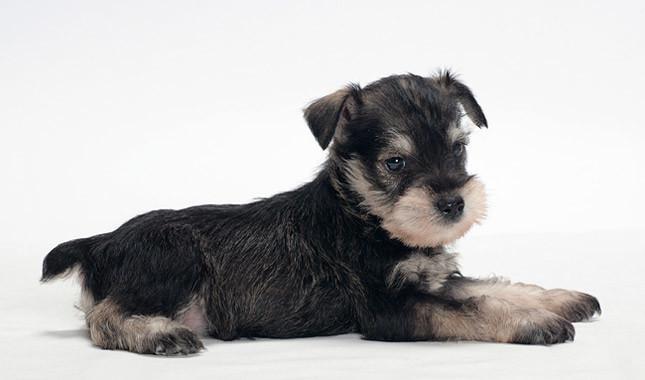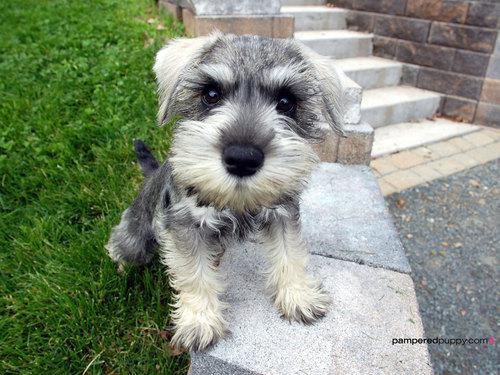The first image is the image on the left, the second image is the image on the right. Assess this claim about the two images: "Right image shows at least one schnauzer dog sitting in a car.". Correct or not? Answer yes or no. No. The first image is the image on the left, the second image is the image on the right. For the images displayed, is the sentence "A dog in one image is mostly black with light colored bushy eyebrows and a matching light-colored beard." factually correct? Answer yes or no. Yes. 